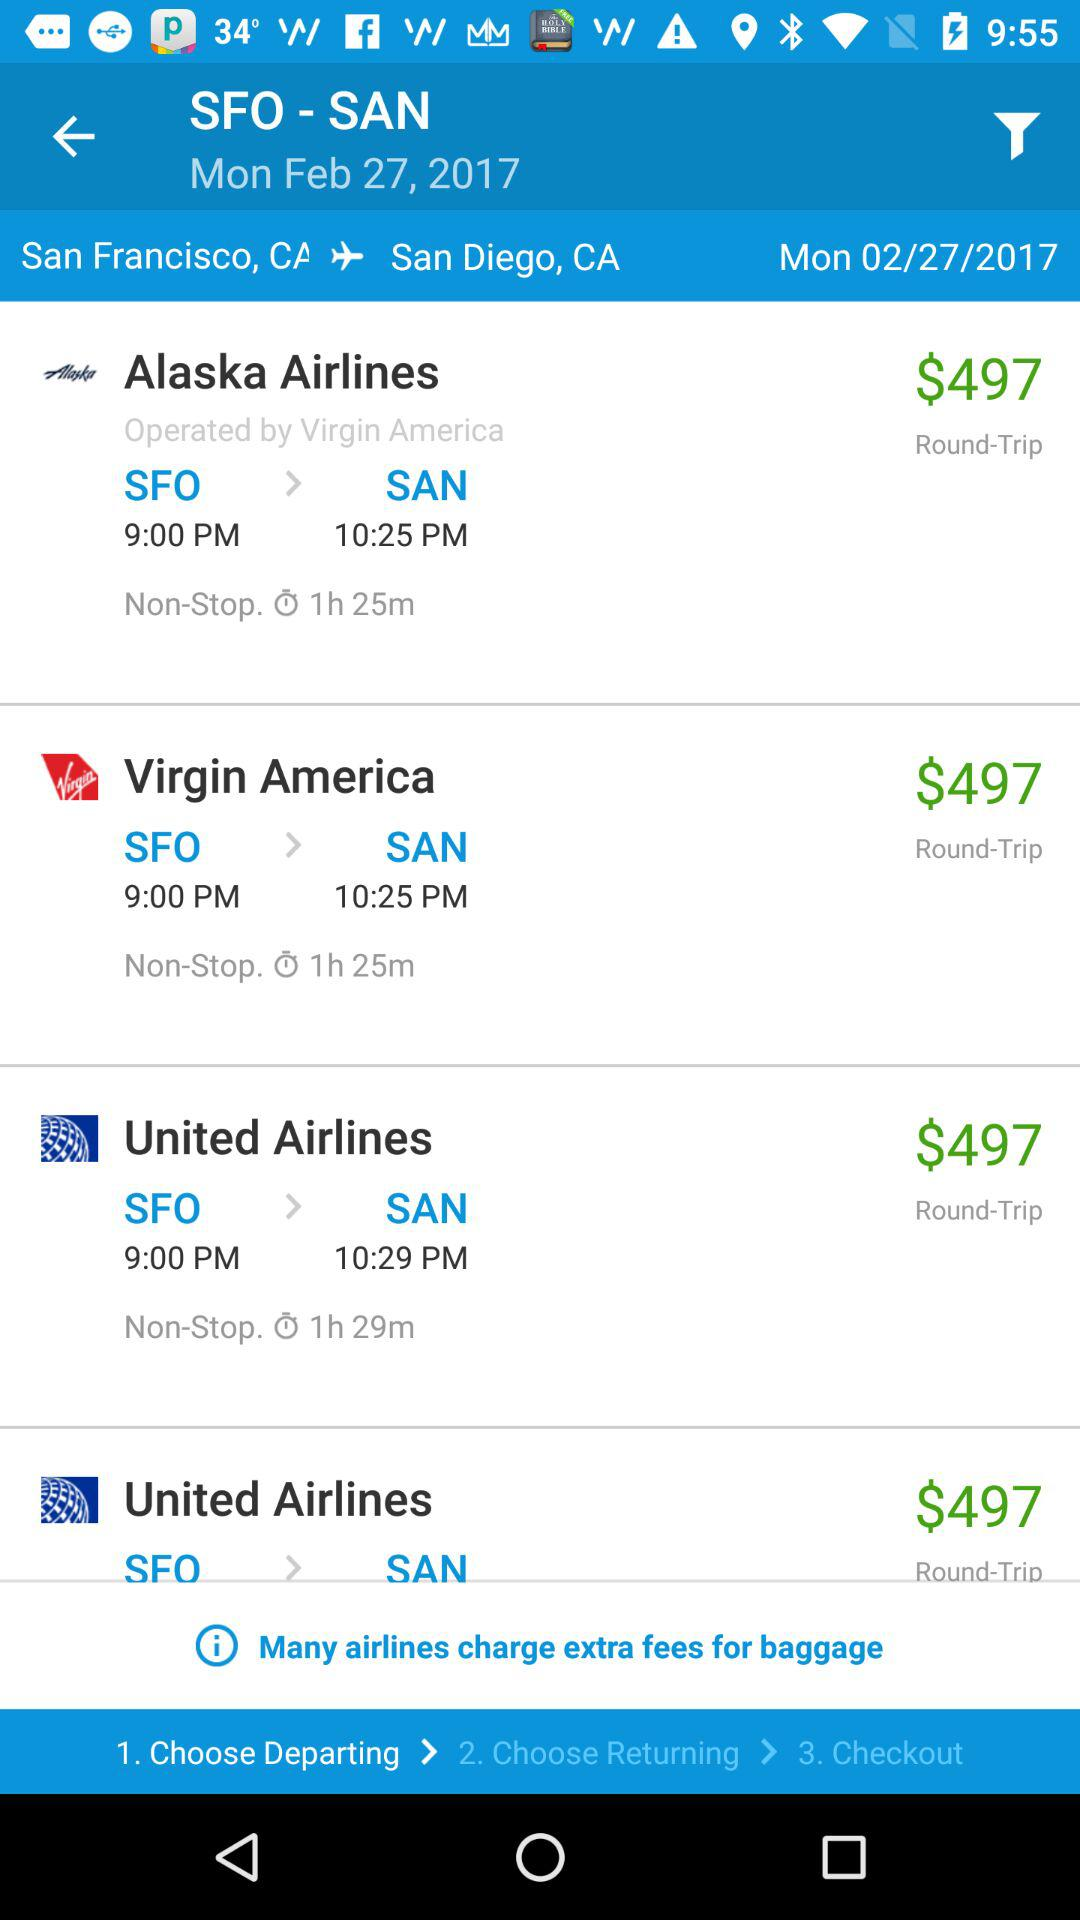What is the date? The date is Monday, February 27, 2017. 